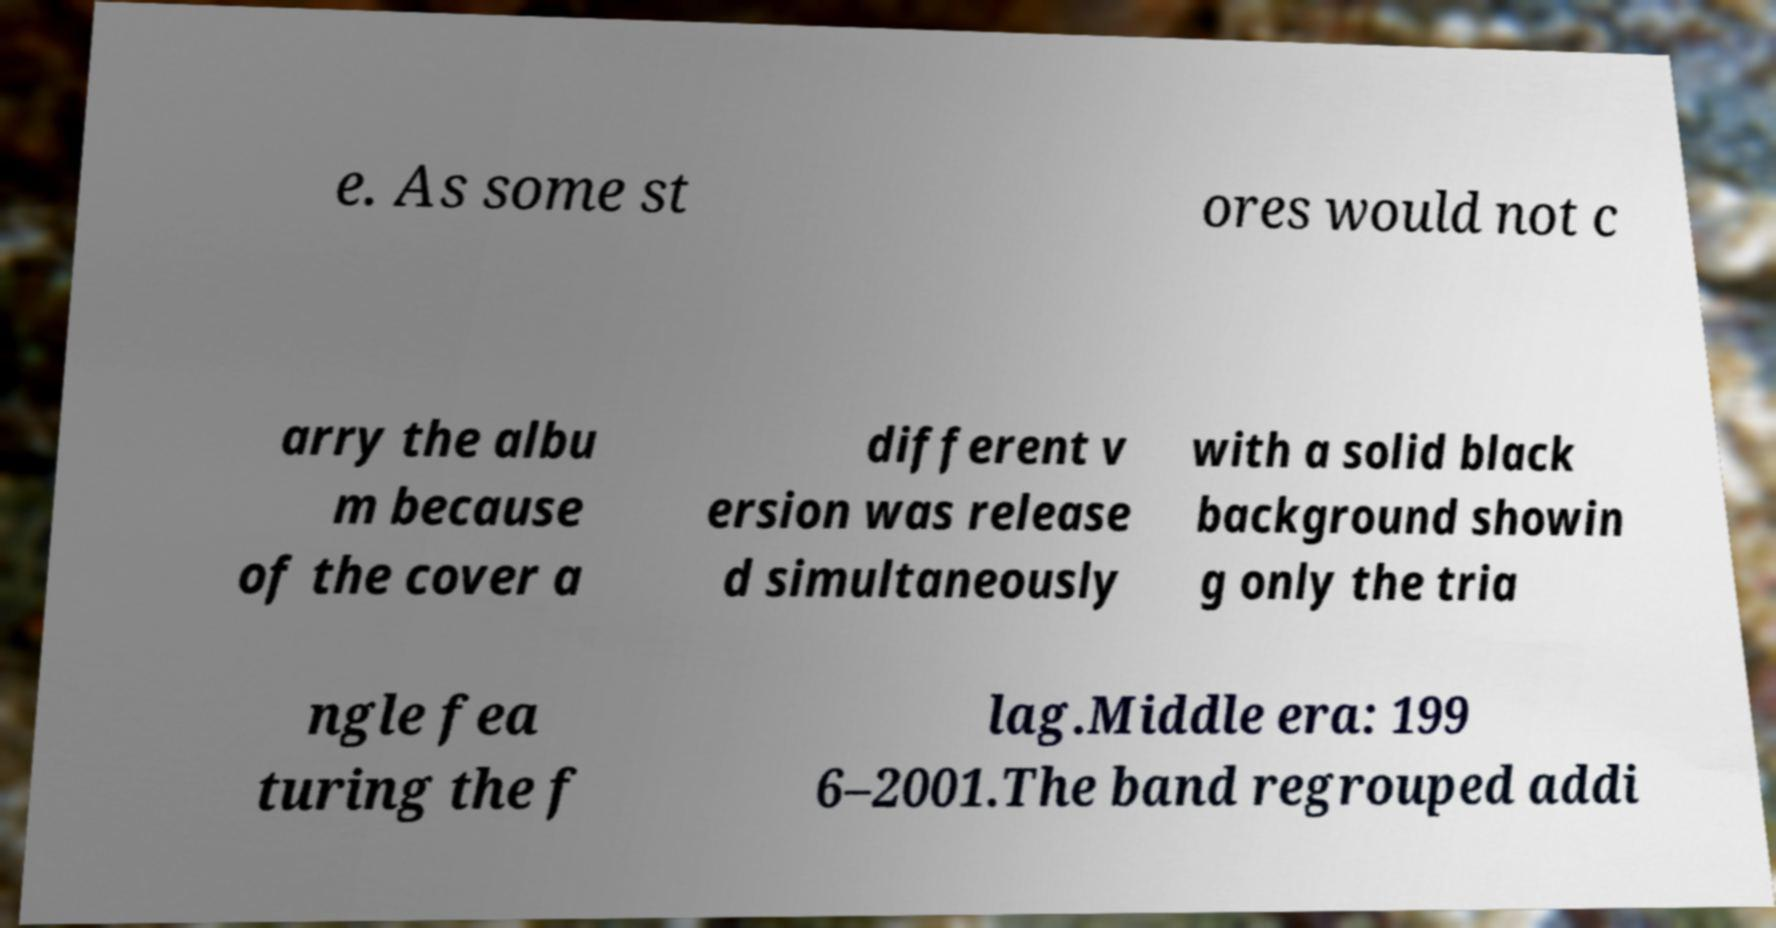For documentation purposes, I need the text within this image transcribed. Could you provide that? e. As some st ores would not c arry the albu m because of the cover a different v ersion was release d simultaneously with a solid black background showin g only the tria ngle fea turing the f lag.Middle era: 199 6–2001.The band regrouped addi 